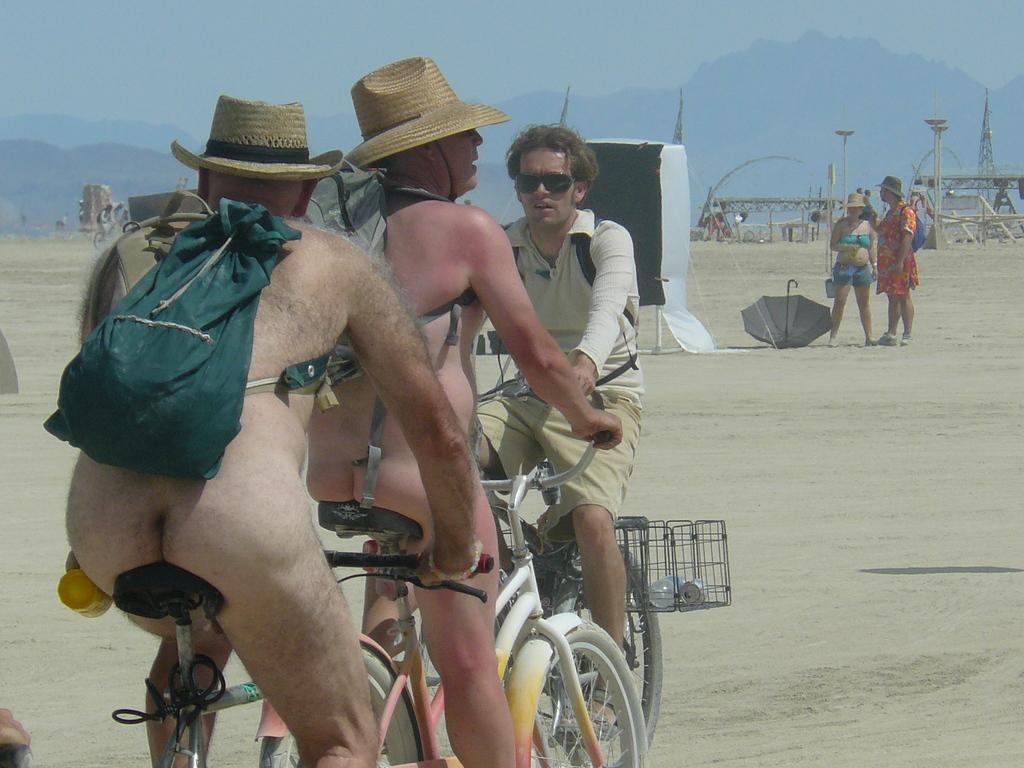What are the persons doing in the image? The persons are on a bicycle in the image. What can be seen in the background of the image? There is a sky visible in the background of the image. What object is present in the image besides the bicycle and persons? There is an umbrella in the image. How much salt is sprinkled on the hydrant in the image? There is no hydrant or salt present in the image. What type of ray is flying above the persons on the bicycle in the image? There is no ray present in the image. 